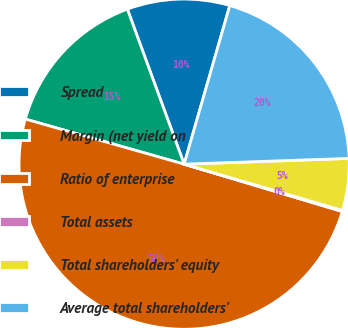Convert chart to OTSL. <chart><loc_0><loc_0><loc_500><loc_500><pie_chart><fcel>Spread<fcel>Margin (net yield on<fcel>Ratio of enterprise<fcel>Total assets<fcel>Total shareholders' equity<fcel>Average total shareholders'<nl><fcel>10.05%<fcel>15.01%<fcel>49.77%<fcel>0.11%<fcel>5.08%<fcel>19.98%<nl></chart> 